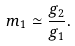<formula> <loc_0><loc_0><loc_500><loc_500>m _ { 1 } \simeq \frac { g _ { 2 } } { g _ { 1 } } .</formula> 